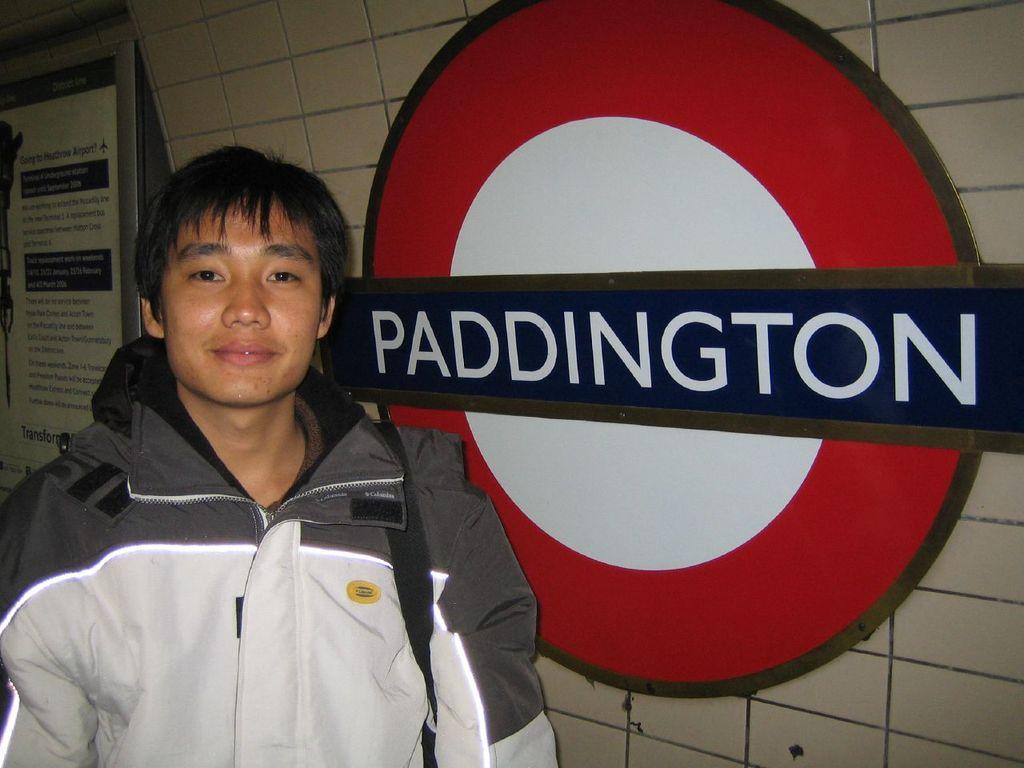<image>
Give a short and clear explanation of the subsequent image. A man standing by a sign that says "Paddington" 